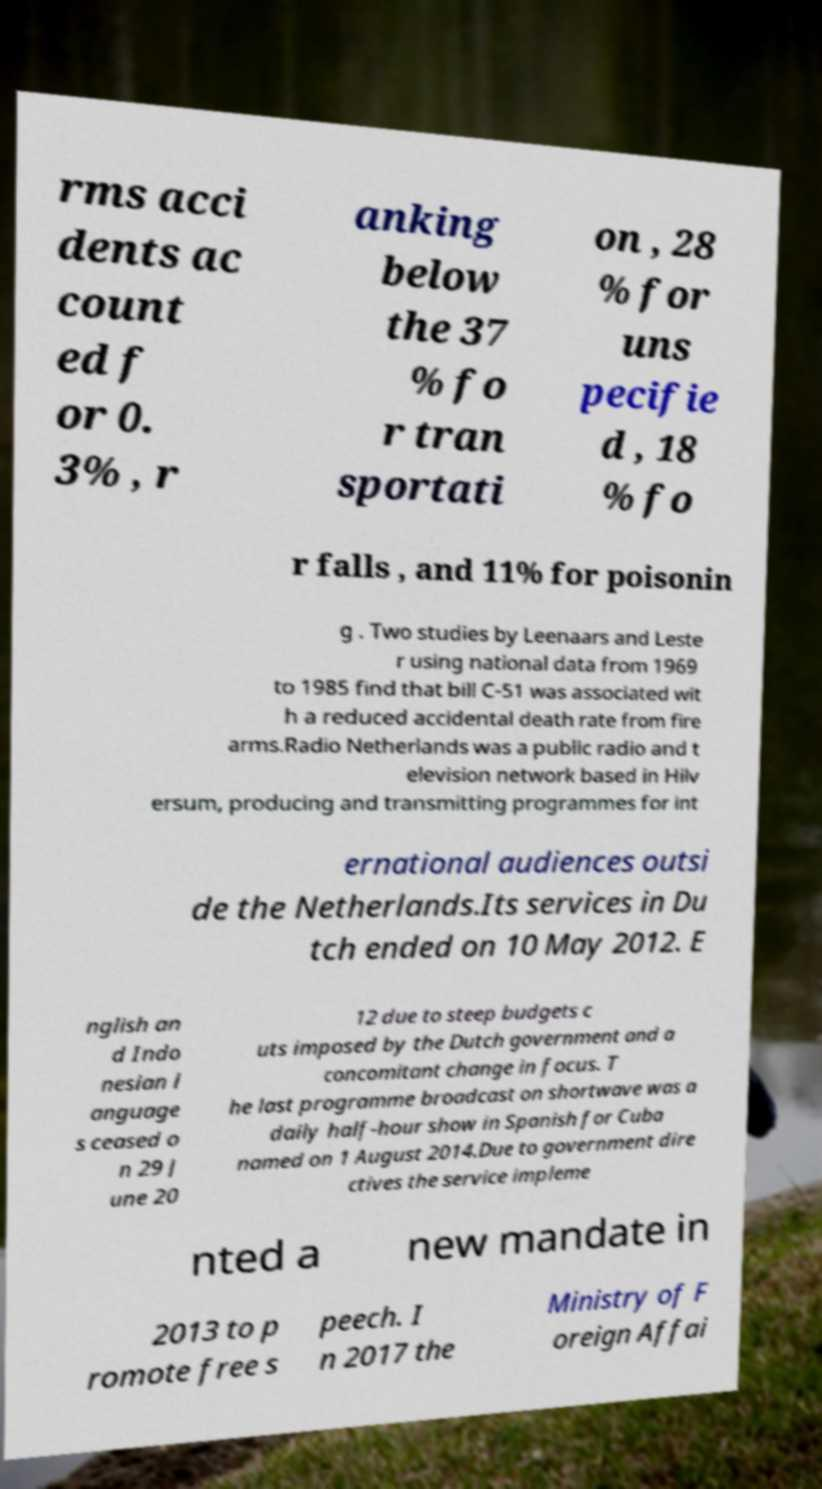Can you read and provide the text displayed in the image?This photo seems to have some interesting text. Can you extract and type it out for me? rms acci dents ac count ed f or 0. 3% , r anking below the 37 % fo r tran sportati on , 28 % for uns pecifie d , 18 % fo r falls , and 11% for poisonin g . Two studies by Leenaars and Leste r using national data from 1969 to 1985 find that bill C-51 was associated wit h a reduced accidental death rate from fire arms.Radio Netherlands was a public radio and t elevision network based in Hilv ersum, producing and transmitting programmes for int ernational audiences outsi de the Netherlands.Its services in Du tch ended on 10 May 2012. E nglish an d Indo nesian l anguage s ceased o n 29 J une 20 12 due to steep budgets c uts imposed by the Dutch government and a concomitant change in focus. T he last programme broadcast on shortwave was a daily half-hour show in Spanish for Cuba named on 1 August 2014.Due to government dire ctives the service impleme nted a new mandate in 2013 to p romote free s peech. I n 2017 the Ministry of F oreign Affai 